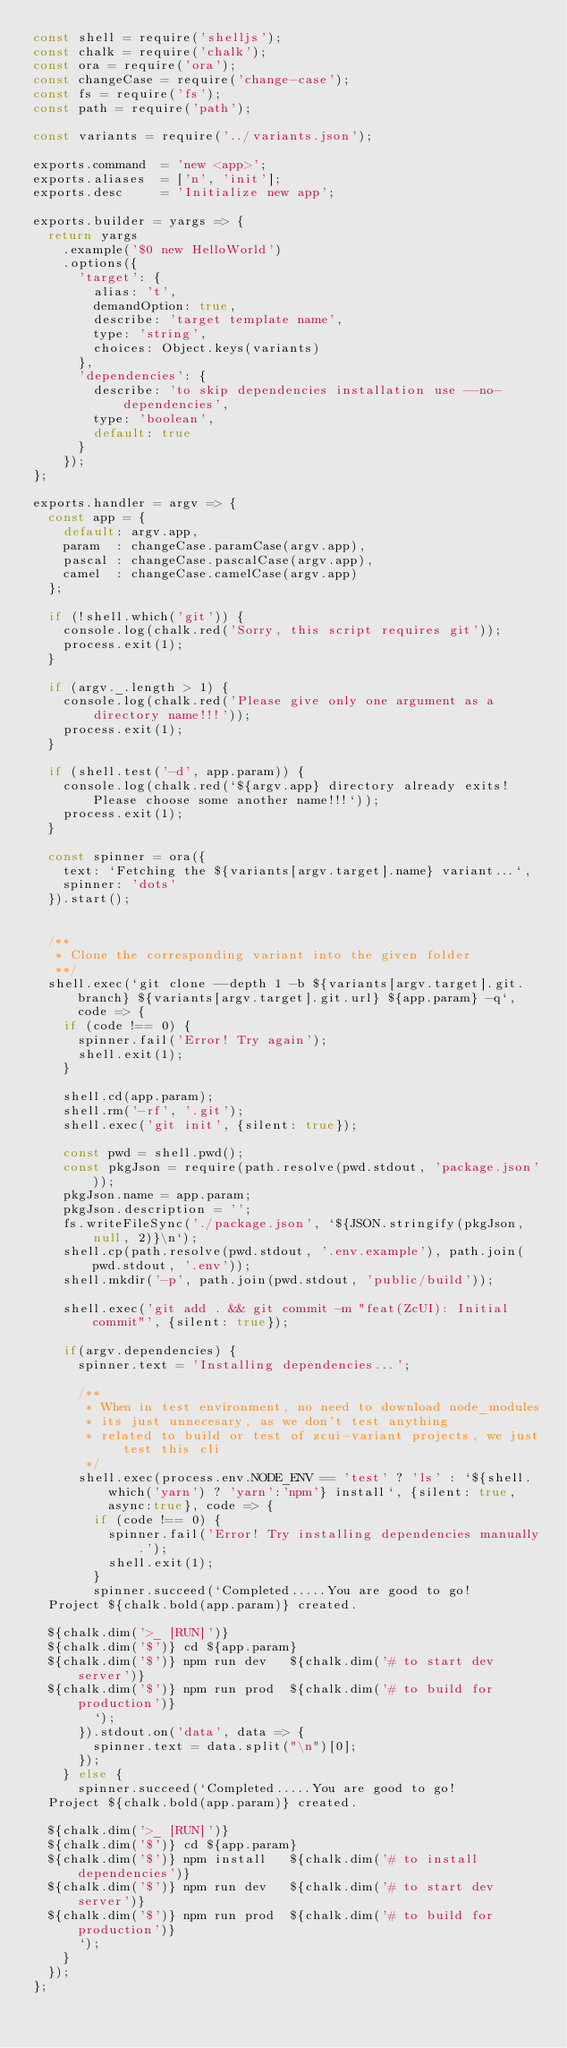Convert code to text. <code><loc_0><loc_0><loc_500><loc_500><_JavaScript_>const shell = require('shelljs');
const chalk = require('chalk');
const ora = require('ora');
const changeCase = require('change-case');
const fs = require('fs');
const path = require('path');

const variants = require('../variants.json');

exports.command  = 'new <app>';
exports.aliases  = ['n', 'init'];
exports.desc     = 'Initialize new app';

exports.builder = yargs => {
  return yargs
    .example('$0 new HelloWorld')
    .options({
      'target': {
        alias: 't',
        demandOption: true,
        describe: 'target template name',
        type: 'string',
        choices: Object.keys(variants)
      },
      'dependencies': {
        describe: 'to skip dependencies installation use --no-dependencies',
        type: 'boolean',
        default: true
      }
    });
};

exports.handler = argv => {
  const app = {
    default: argv.app,
    param  : changeCase.paramCase(argv.app),
    pascal : changeCase.pascalCase(argv.app),
    camel  : changeCase.camelCase(argv.app)
  };

  if (!shell.which('git')) {
    console.log(chalk.red('Sorry, this script requires git'));
    process.exit(1);
  }

  if (argv._.length > 1) {
    console.log(chalk.red('Please give only one argument as a directory name!!!'));
    process.exit(1);
  }

  if (shell.test('-d', app.param)) {
    console.log(chalk.red(`${argv.app} directory already exits! Please choose some another name!!!`));
    process.exit(1);
  }

  const spinner = ora({
    text: `Fetching the ${variants[argv.target].name} variant...`,
    spinner: 'dots'
  }).start();


  /**
   * Clone the corresponding variant into the given folder
   **/
  shell.exec(`git clone --depth 1 -b ${variants[argv.target].git.branch} ${variants[argv.target].git.url} ${app.param} -q`, code => {
    if (code !== 0) {
      spinner.fail('Error! Try again');
      shell.exit(1);
    }

    shell.cd(app.param);
    shell.rm('-rf', '.git');
    shell.exec('git init', {silent: true});

    const pwd = shell.pwd();
    const pkgJson = require(path.resolve(pwd.stdout, 'package.json'));
    pkgJson.name = app.param;
    pkgJson.description = '';
    fs.writeFileSync('./package.json', `${JSON.stringify(pkgJson, null, 2)}\n`);
    shell.cp(path.resolve(pwd.stdout, '.env.example'), path.join(pwd.stdout, '.env'));
    shell.mkdir('-p', path.join(pwd.stdout, 'public/build'));

    shell.exec('git add . && git commit -m "feat(ZcUI): Initial commit"', {silent: true});

    if(argv.dependencies) {
      spinner.text = 'Installing dependencies...';

      /**
       * When in test environment, no need to download node_modules
       * its just unnecesary, as we don't test anything 
       * related to build or test of zcui-variant projects, we just test this cli
       */
      shell.exec(process.env.NODE_ENV == 'test' ? 'ls' : `${shell.which('yarn') ? 'yarn':'npm'} install`, {silent: true, async:true}, code => {
        if (code !== 0) {
          spinner.fail('Error! Try installing dependencies manually.');
          shell.exit(1);
        }
        spinner.succeed(`Completed.....You are good to go!
  Project ${chalk.bold(app.param)} created.

  ${chalk.dim('>_ [RUN]')}
  ${chalk.dim('$')} cd ${app.param}
  ${chalk.dim('$')} npm run dev   ${chalk.dim('# to start dev server')}
  ${chalk.dim('$')} npm run prod  ${chalk.dim('# to build for production')}
        `);
      }).stdout.on('data', data => {
        spinner.text = data.split("\n")[0];
      });
    } else {
      spinner.succeed(`Completed.....You are good to go!
  Project ${chalk.bold(app.param)} created.

  ${chalk.dim('>_ [RUN]')}
  ${chalk.dim('$')} cd ${app.param}
  ${chalk.dim('$')} npm install   ${chalk.dim('# to install dependencies')}
  ${chalk.dim('$')} npm run dev   ${chalk.dim('# to start dev server')}
  ${chalk.dim('$')} npm run prod  ${chalk.dim('# to build for production')}
      `);
    }
  });
};

</code> 